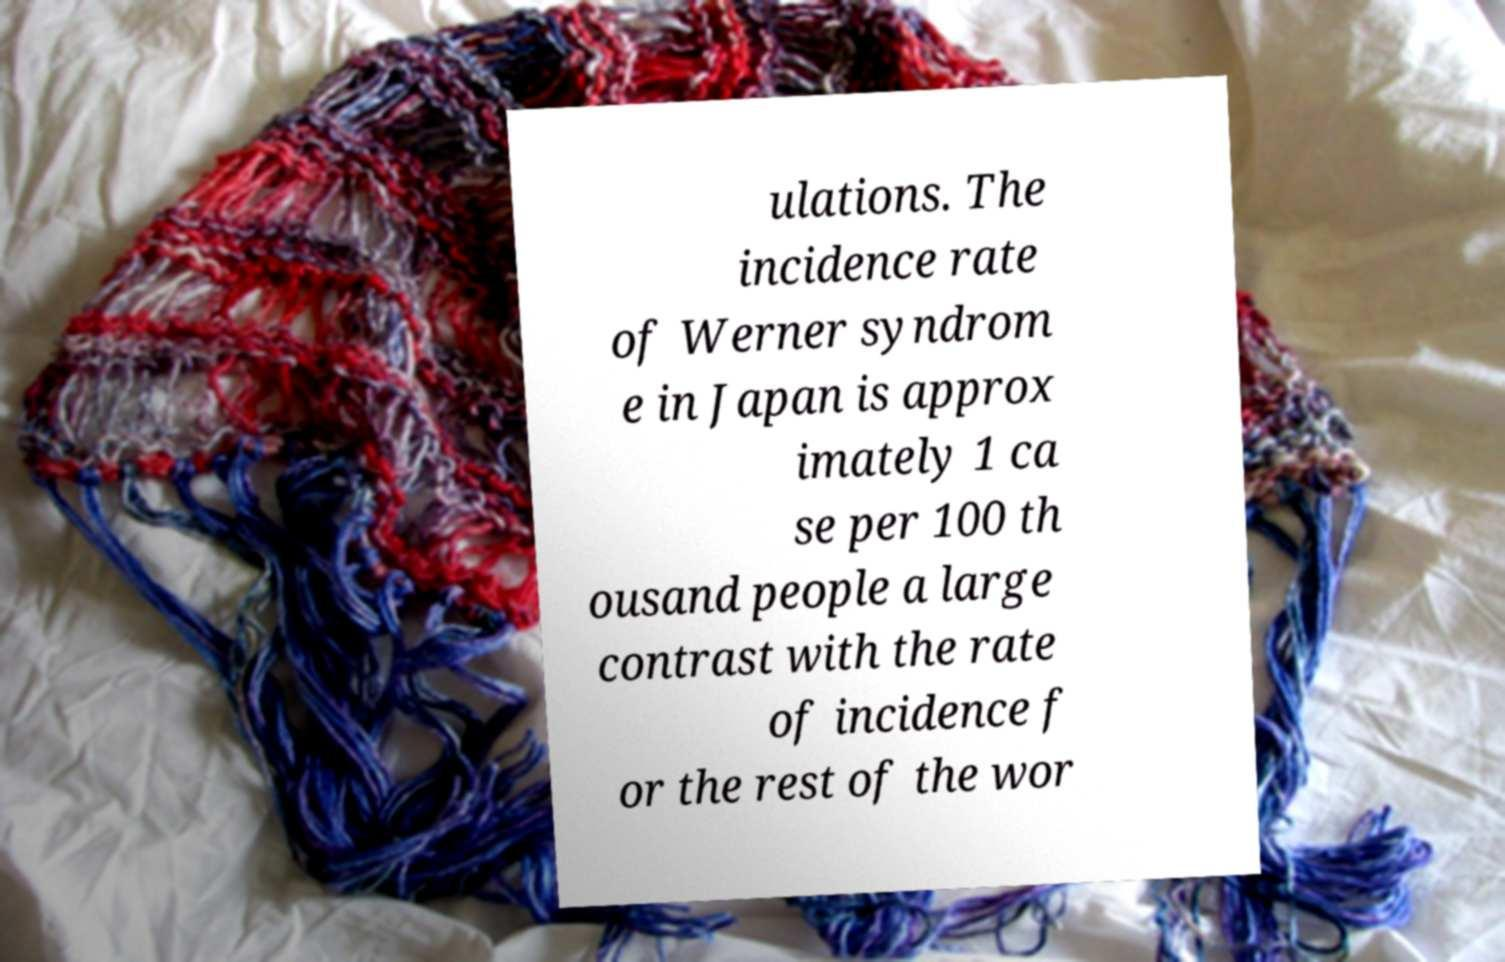I need the written content from this picture converted into text. Can you do that? ulations. The incidence rate of Werner syndrom e in Japan is approx imately 1 ca se per 100 th ousand people a large contrast with the rate of incidence f or the rest of the wor 